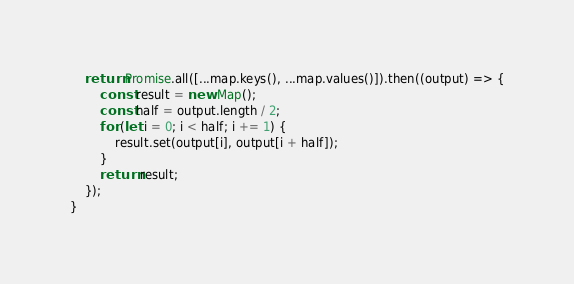Convert code to text. <code><loc_0><loc_0><loc_500><loc_500><_JavaScript_>	return Promise.all([...map.keys(), ...map.values()]).then((output) => {
		const result = new Map();
		const half = output.length / 2;
		for (let i = 0; i < half; i += 1) {
			result.set(output[i], output[i + half]);
		}
		return result;
	});
}
</code> 